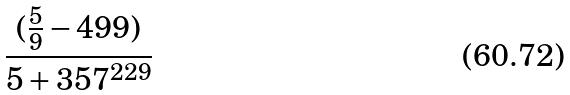Convert formula to latex. <formula><loc_0><loc_0><loc_500><loc_500>\frac { ( \frac { 5 } { 9 } - 4 9 9 ) } { 5 + 3 5 7 ^ { 2 2 9 } }</formula> 